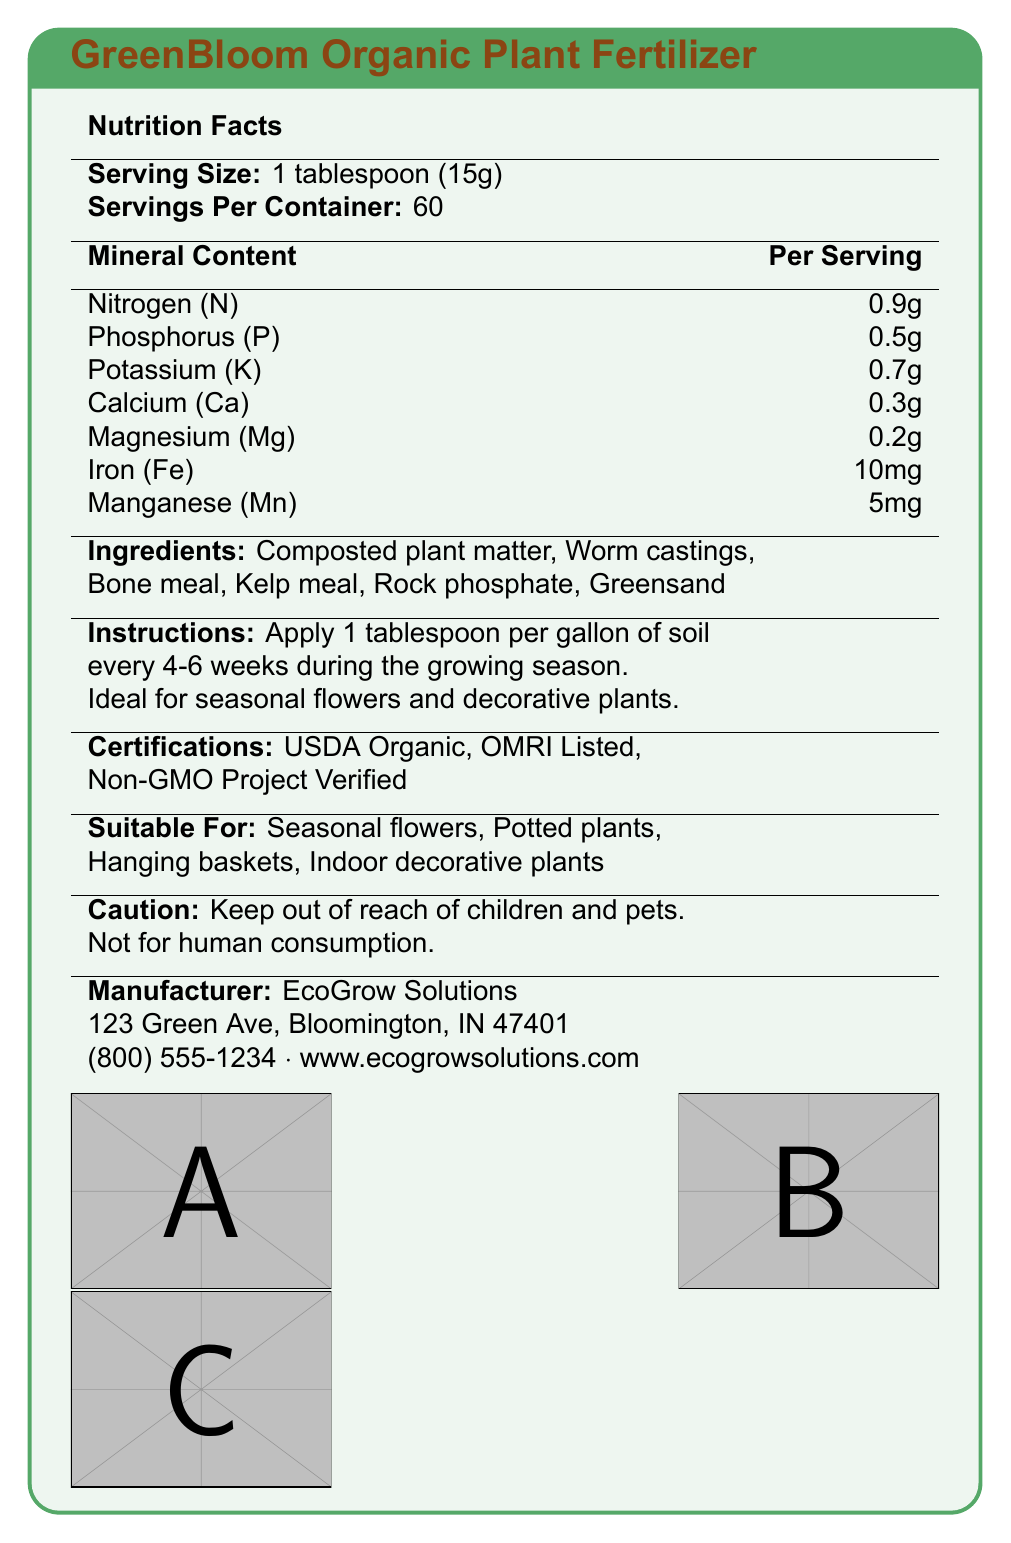what is the name of the product? The product name is prominently displayed at the top of the document within the title section.
Answer: GreenBloom Organic Plant Fertilizer what is the recommended application method? The instructions section clearly details how to apply the fertilizer.
Answer: Apply 1 tablespoon per gallon of soil every 4-6 weeks during the growing season. how much Nitrogen (N) is in one serving? The mineral content section lists Nitrogen (N) with an amount of 0.9g per serving.
Answer: 0.9g which minerals are present in the fertilizer? The mineral content section outlines all the minerals included in the fertilizer.
Answer: Nitrogen (N), Phosphorus (P), Potassium (K), Calcium (Ca), Magnesium (Mg), Iron (Fe), Manganese (Mn) how many servings per container? The nutrition facts section states that there are 60 servings per container.
Answer: 60 which certification is not listed for this product? A. USDA Organic B. OMRI Listed C. Fair Trade D. Non-GMO Project Verified The certifications listed are USDA Organic, OMRI Listed, and Non-GMO Project Verified. Fair Trade is not mentioned.
Answer: C. Fair Trade which of the following is a benefit of using this fertilizer? A. Improves soil structure B. Deters pests C. Enhances plant aroma D. Increases plant height The environmental benefits section mentions that the fertilizer improves soil structure.
Answer: A. Improves soil structure is this fertilizer suitable for indoor decorative plants? The suitable for section lists indoor decorative plants as one of the applications.
Answer: Yes is the fertilizer safe for human consumption? The caution section clearly states "Not for human consumption."
Answer: No who manufactures this fertilizer? The manufacturer information section mentions that EcoGrow Solutions is the manufacturer.
Answer: EcoGrow Solutions how is this fertilizer beneficial to the soil structure? The environmental benefits section provides detailed information on the benefits of using this fertilizer.
Answer: It improves soil structure, enhances water retention, promotes beneficial microorganisms, and reduces carbon footprint. could you provide a summary of the entire document? The document thoroughly describes the product details, usage instructions, and benefits, providing a comprehensive overview of the fertilizer.
Answer: The document provides information about GreenBloom Organic Plant Fertilizer, an organic, plant-based fertilizer suitable for decorative plants. It includes nutrition facts, mineral content, instructions for use, certifications, environmental benefits, caution, and manufacturer details. what is the amount of Magnesium (Mg) in the fertilizer? The mineral content section lists Magnesium (Mg) with an amount of 0.2g per serving.
Answer: 0.2g what element is present in the smallest amount in the fertilizer? The mineral content section shows that Magnesium (Mg) has the smallest amount at 0.2g per serving.
Answer: Magnesium (Mg) 